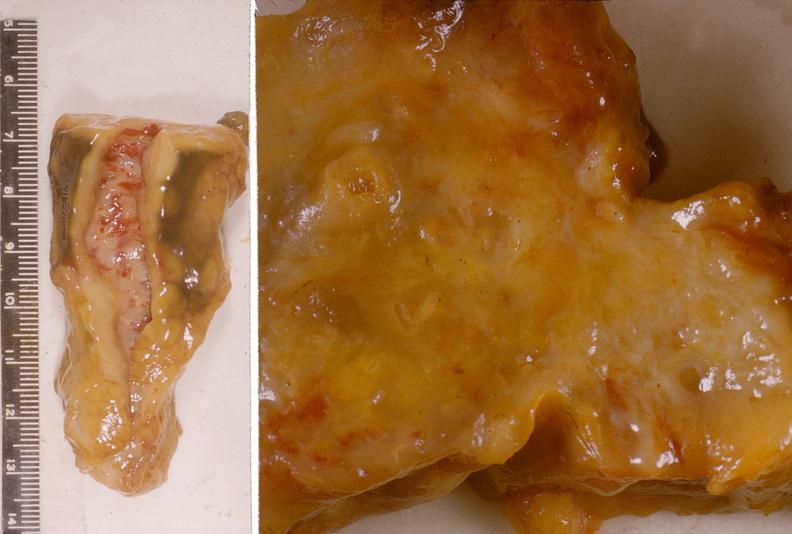does this image show adenocarcinoma, head of pancreas?
Answer the question using a single word or phrase. Yes 